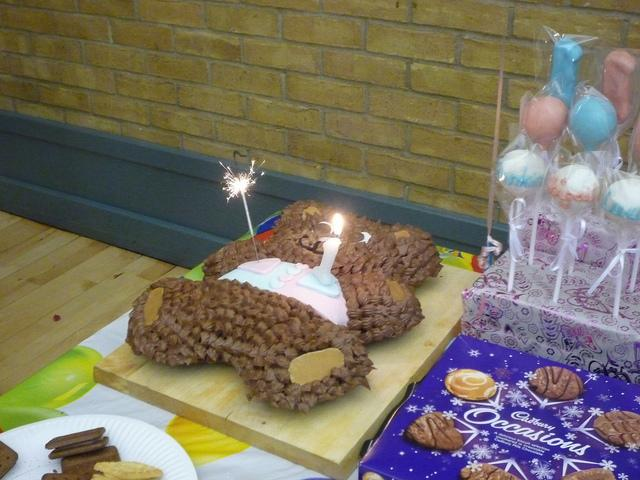What is the cake in the shape of? teddy bear 